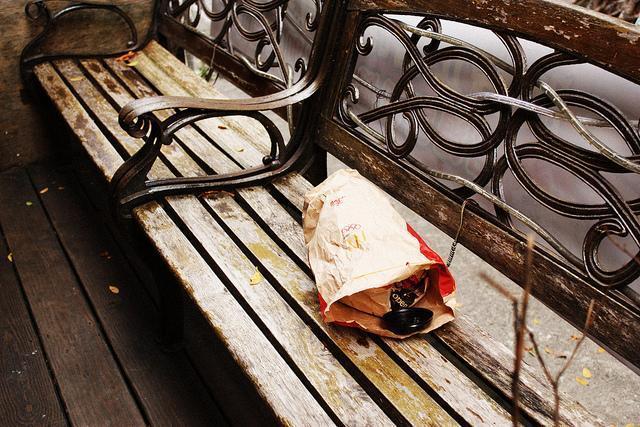How many boards make up the bench seat?
Give a very brief answer. 5. 